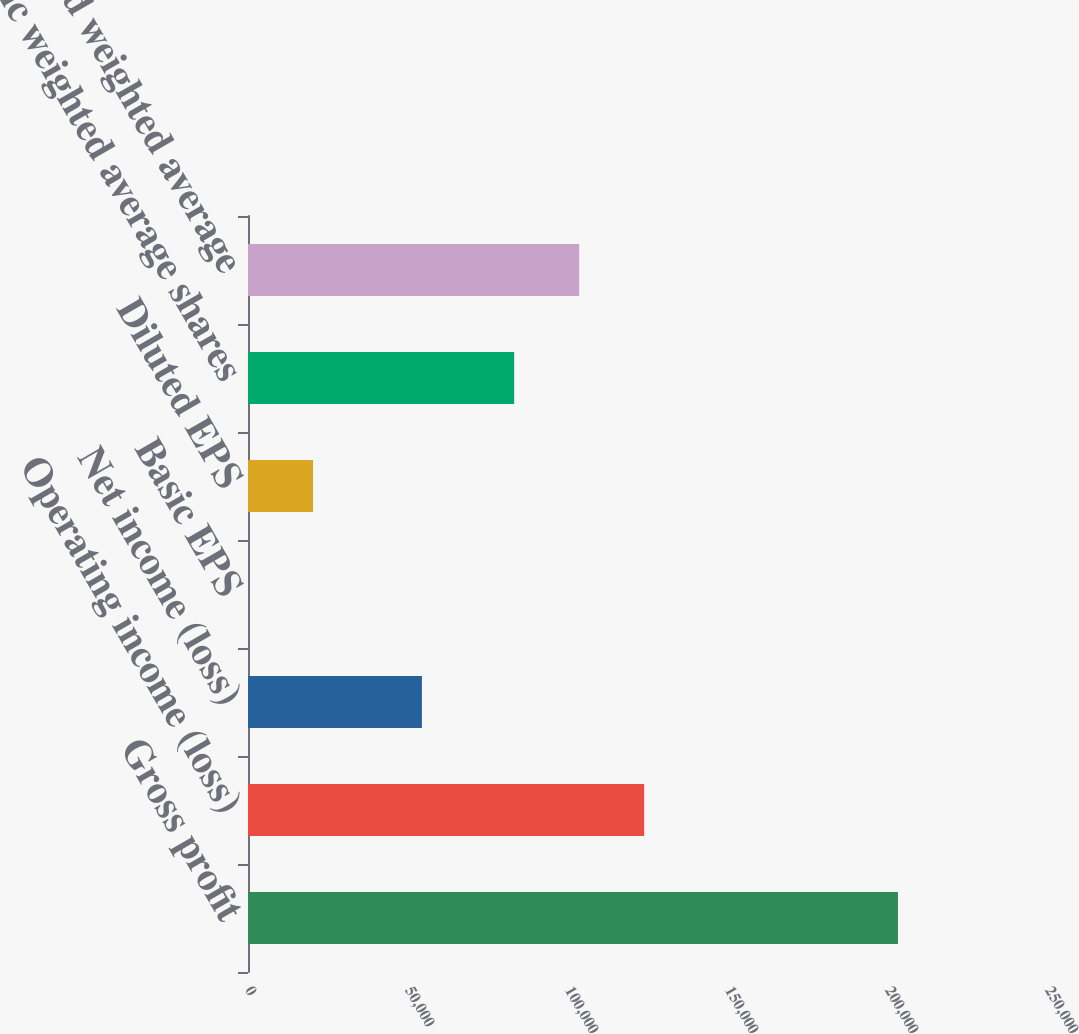<chart> <loc_0><loc_0><loc_500><loc_500><bar_chart><fcel>Gross profit<fcel>Operating income (loss)<fcel>Net income (loss)<fcel>Basic EPS<fcel>Diluted EPS<fcel>Basic weighted average shares<fcel>Diluted weighted average<nl><fcel>203113<fcel>123802<fcel>54351<fcel>0.65<fcel>20311.9<fcel>83180<fcel>103491<nl></chart> 